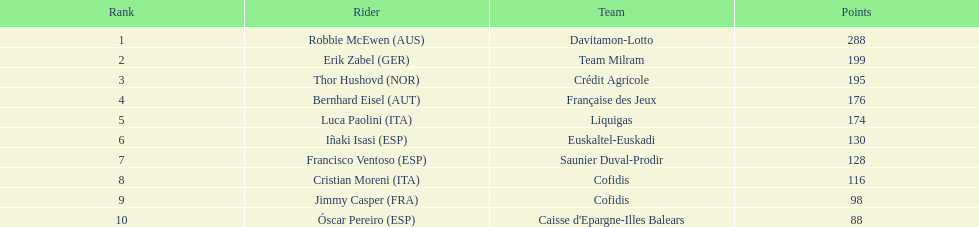How many more points did erik zabel score than franciso ventoso? 71. 